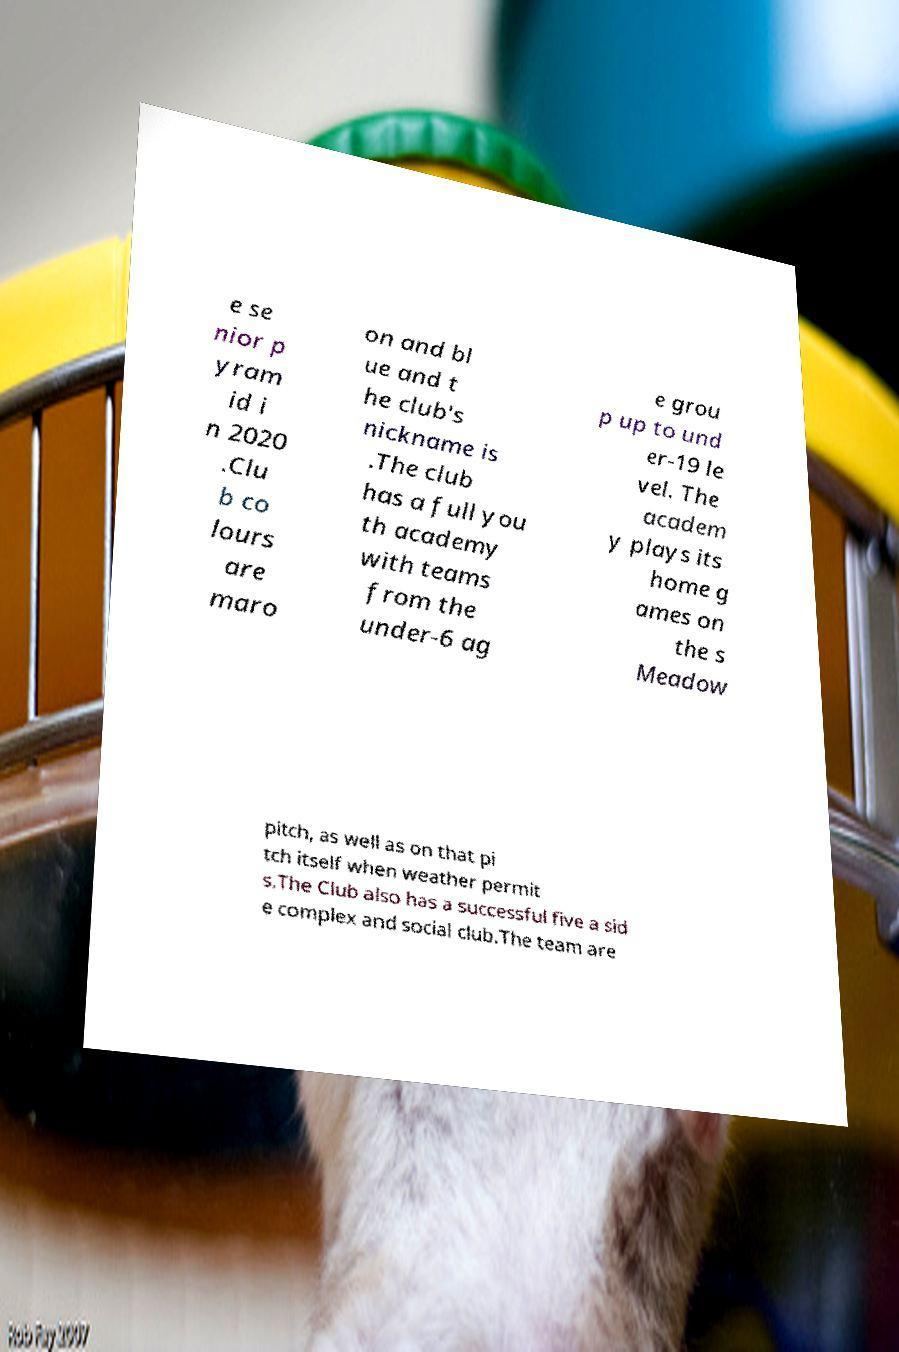Could you assist in decoding the text presented in this image and type it out clearly? e se nior p yram id i n 2020 .Clu b co lours are maro on and bl ue and t he club's nickname is .The club has a full you th academy with teams from the under-6 ag e grou p up to und er-19 le vel. The academ y plays its home g ames on the s Meadow pitch, as well as on that pi tch itself when weather permit s.The Club also has a successful five a sid e complex and social club.The team are 